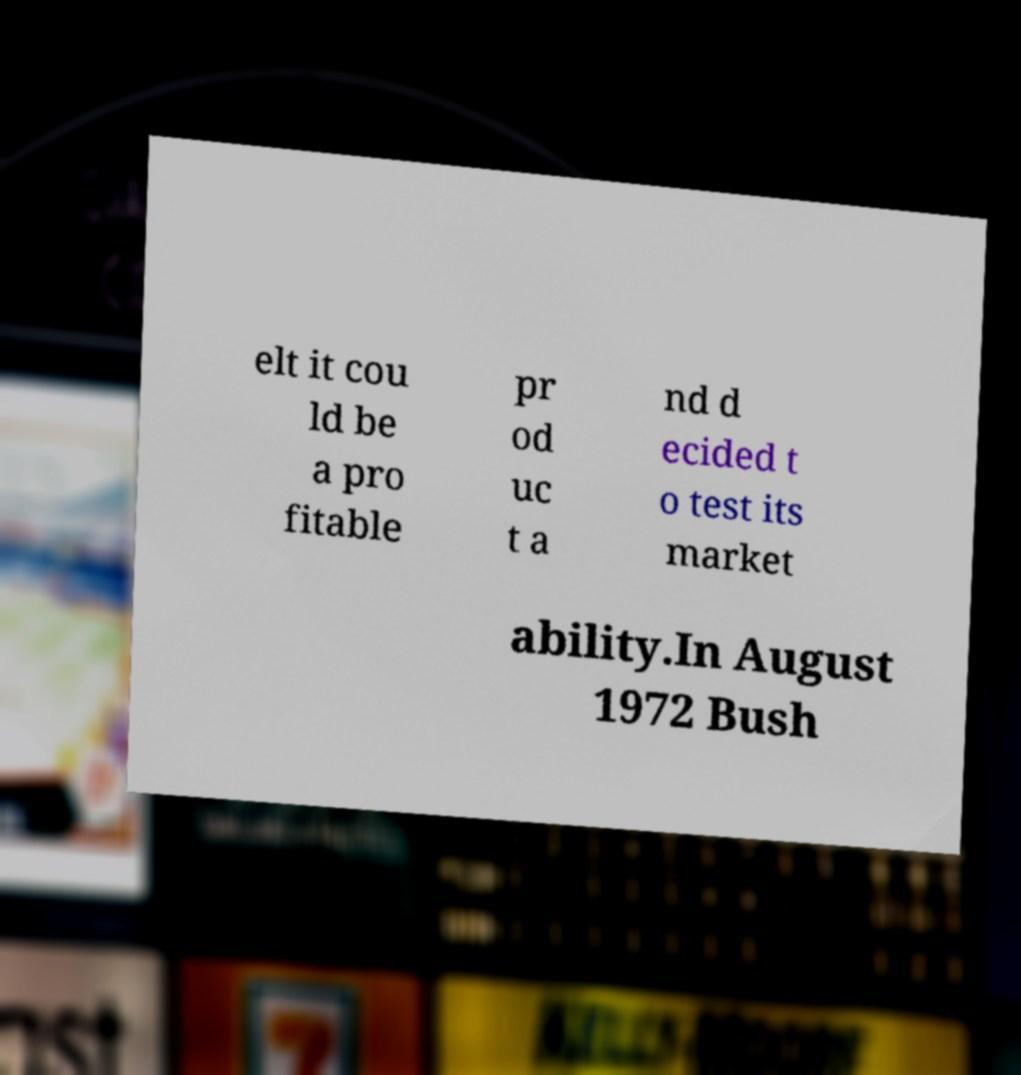Could you extract and type out the text from this image? elt it cou ld be a pro fitable pr od uc t a nd d ecided t o test its market ability.In August 1972 Bush 